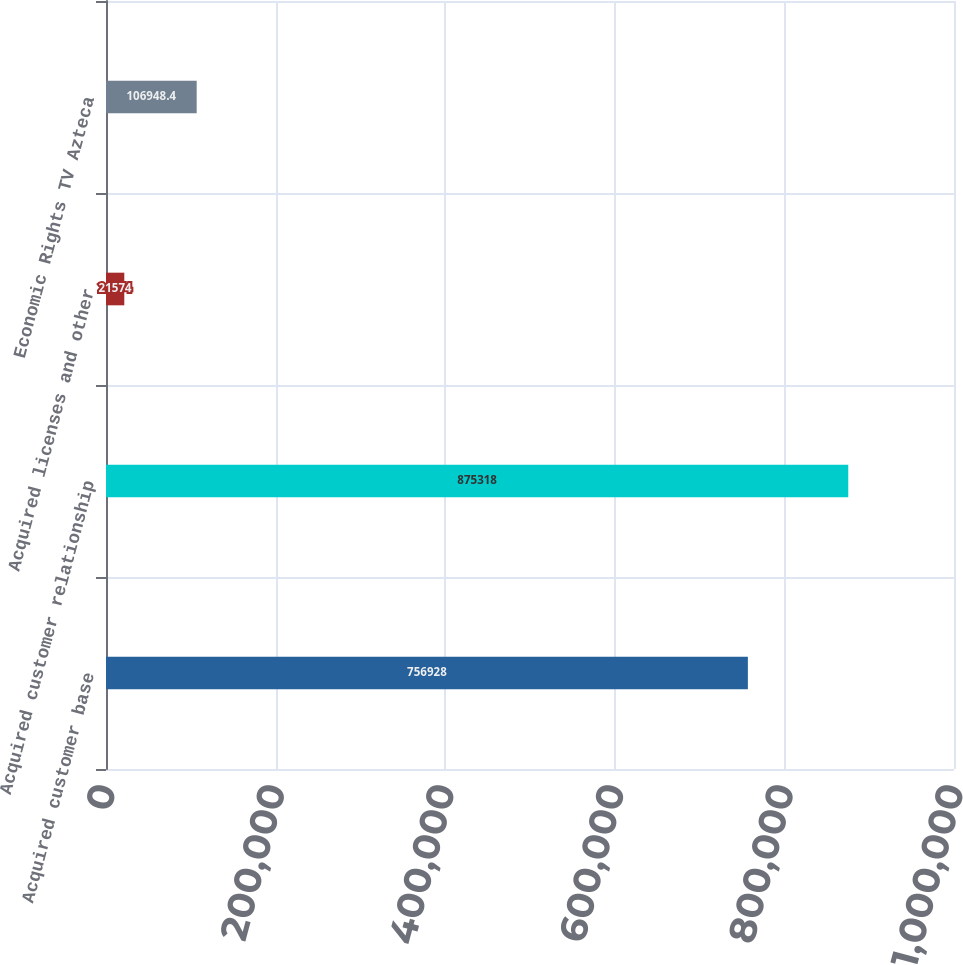Convert chart. <chart><loc_0><loc_0><loc_500><loc_500><bar_chart><fcel>Acquired customer base<fcel>Acquired customer relationship<fcel>Acquired licenses and other<fcel>Economic Rights TV Azteca<nl><fcel>756928<fcel>875318<fcel>21574<fcel>106948<nl></chart> 